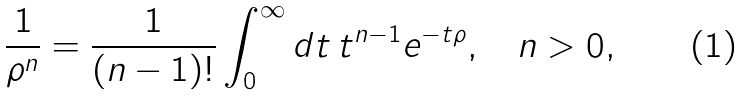Convert formula to latex. <formula><loc_0><loc_0><loc_500><loc_500>\frac { 1 } { \rho ^ { n } } = \frac { 1 } { ( n - 1 ) ! } \int _ { 0 } ^ { \infty } d t \, t ^ { n - 1 } e ^ { - t \rho } , \quad n > 0 ,</formula> 